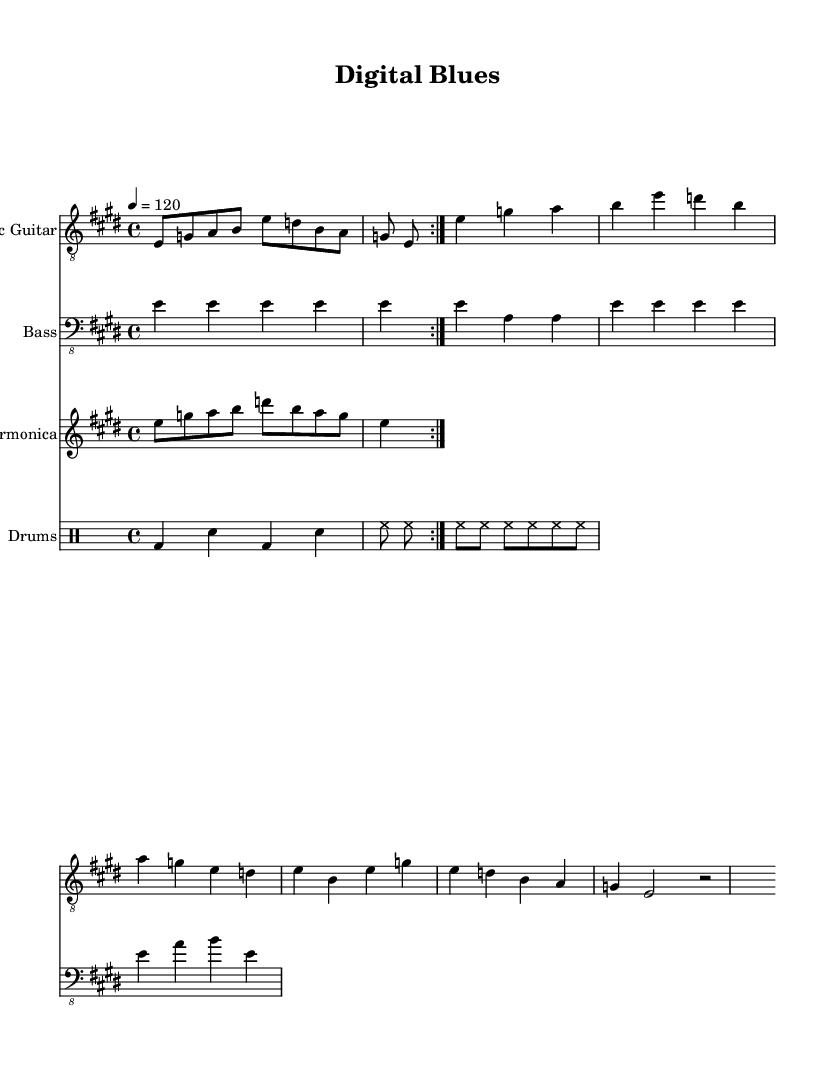What is the key signature of this music? The key signature shown in the music indicates E major, which has four sharps: F#, C#, G#, and D#. This is evident from the presence of the sharp symbols at the beginning of the staff.
Answer: E major What is the time signature of this music? The time signature displayed in the music is 4/4, which indicates that there are four beats in each measure and the quarter note gets one beat. This is clearly indicated at the beginning of the staff.
Answer: 4/4 What is the tempo indication for this piece? The tempo marking shows "4 = 120," meaning that the quarter note (the 4 in the tempo marking) is to be played at 120 beats per minute. This is a standard way to express tempo in sheet music.
Answer: 120 How many measures are in the verse section? To ascertain this, we locate the verse section and count the measures from its beginning to the end. The verse contains 4 measures total. Thus, the count confirms this conclusion.
Answer: 4 What type of guitar is used in this piece? The score specifies "Electric Guitar" as the instrument, which is indicated in the staff label at the beginning of the corresponding music section. This clearly identifies the type of guitar used.
Answer: Electric Guitar What rhythmic pattern is used in the drums? The drumming part features a basic rhythm comprising a bass drum and snare alternating pattern followed by a consistent hi-hat rhythm, as detailed in the drumming notation. This indicates a straightforward rock beat common in blues music.
Answer: Basic pattern What solo instrument is specified in this music? The music includes a part labeled "Harmonica," which denotes that the harmonica is the specific instrument featured for the solo section within the composition. This is explicitly noted in the staff name area.
Answer: Harmonica 